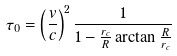Convert formula to latex. <formula><loc_0><loc_0><loc_500><loc_500>\tau _ { 0 } = \left ( \frac { v } { c } \right ) ^ { 2 } \frac { 1 } { 1 - \frac { r _ { c } } { R } \arctan \frac { R } { r _ { c } } }</formula> 